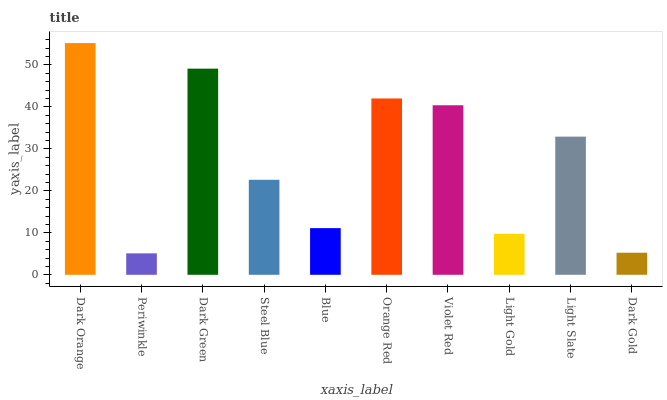Is Dark Green the minimum?
Answer yes or no. No. Is Dark Green the maximum?
Answer yes or no. No. Is Dark Green greater than Periwinkle?
Answer yes or no. Yes. Is Periwinkle less than Dark Green?
Answer yes or no. Yes. Is Periwinkle greater than Dark Green?
Answer yes or no. No. Is Dark Green less than Periwinkle?
Answer yes or no. No. Is Light Slate the high median?
Answer yes or no. Yes. Is Steel Blue the low median?
Answer yes or no. Yes. Is Dark Orange the high median?
Answer yes or no. No. Is Dark Green the low median?
Answer yes or no. No. 